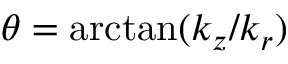<formula> <loc_0><loc_0><loc_500><loc_500>\theta = \arctan ( k _ { z } / k _ { r } )</formula> 